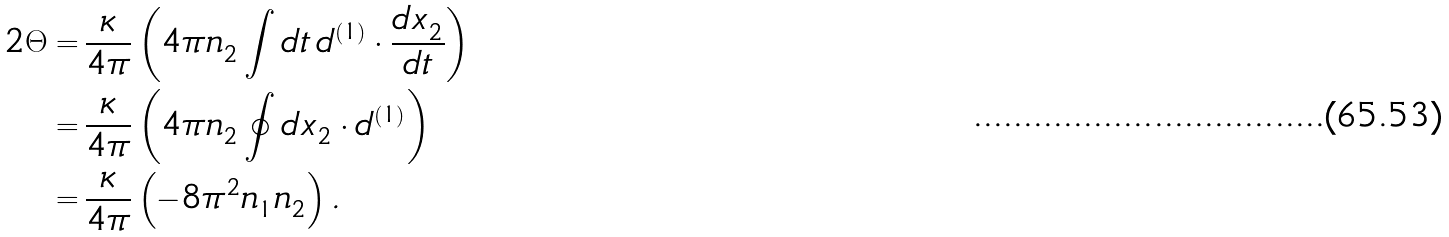Convert formula to latex. <formula><loc_0><loc_0><loc_500><loc_500>2 \Theta = & \, \frac { \kappa } { 4 \pi } \left ( 4 \pi n ^ { \ } _ { 2 } \int d t \, d ^ { ( 1 ) } \cdot \frac { d x ^ { \ } _ { 2 } } { d t } \right ) \\ = & \, \frac { \kappa } { 4 \pi } \left ( 4 \pi n ^ { \ } _ { 2 } \oint d x ^ { \ } _ { 2 } \cdot d ^ { ( 1 ) } \right ) \\ = & \, \frac { \kappa } { 4 \pi } \left ( - 8 \pi ^ { 2 } n ^ { \ } _ { 1 } n ^ { \ } _ { 2 } \right ) .</formula> 